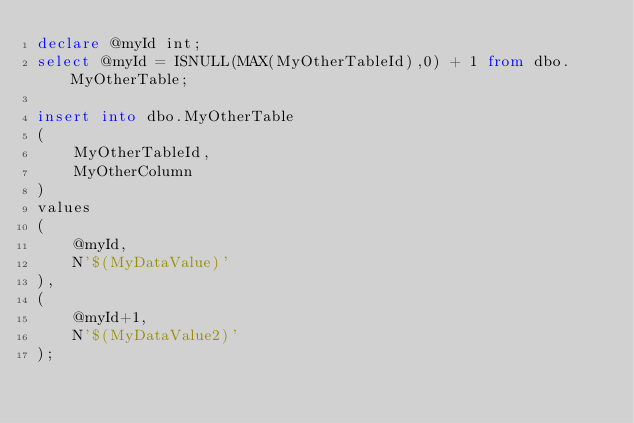<code> <loc_0><loc_0><loc_500><loc_500><_SQL_>declare @myId int;
select @myId = ISNULL(MAX(MyOtherTableId),0) + 1 from dbo.MyOtherTable;

insert into dbo.MyOtherTable
(
	MyOtherTableId,
	MyOtherColumn
)
values
(
	@myId,
	N'$(MyDataValue)'
),
(
	@myId+1,
	N'$(MyDataValue2)'
);</code> 